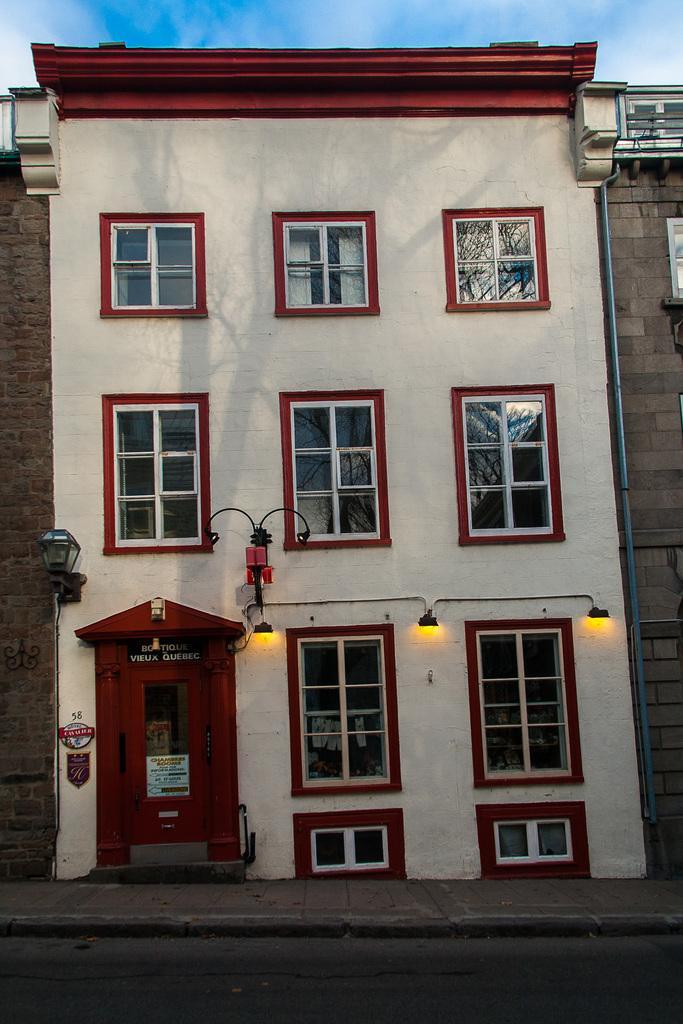In one or two sentences, can you explain what this image depicts? In this image there is a building, walls, windows, door, lights, sky and objects. 